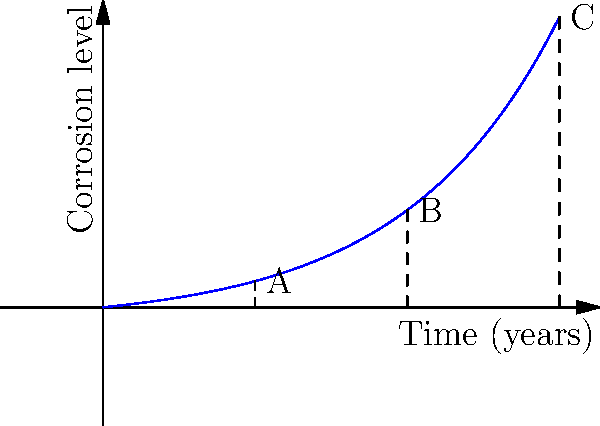Based on the corrosion curve shown in the graph, which represents the relationship between time and corrosion level for aircraft components, estimate the age difference between components B and C if the corrosion level of component A is known to be after 10 years of exposure. To solve this problem, we need to follow these steps:

1. Understand the graph: The graph shows an exponential relationship between time and corrosion level for aircraft components.

2. Identify the points:
   - Point A corresponds to 10 years
   - Point B corresponds to 20 years
   - Point C corresponds to 30 years

3. Calculate the time intervals:
   - From A to B: 20 years - 10 years = 10 years
   - From B to C: 30 years - 20 years = 10 years

4. Compare the intervals:
   The time interval between B and C is the same as the interval between A and B, which is 10 years.

5. Conclude:
   Since we know that point A represents 10 years of exposure, and the interval from B to C is equal to the interval from A to B, we can conclude that the age difference between components B and C is also 10 years.
Answer: 10 years 